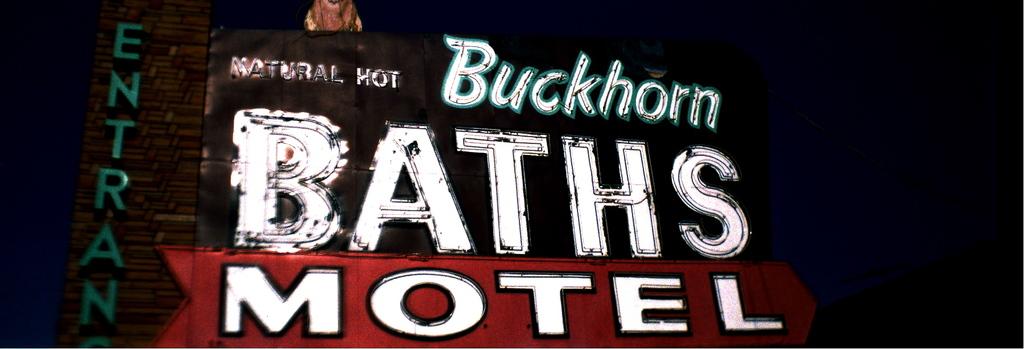What is the name of this motel?
Ensure brevity in your answer.  Buckhorn baths. What kind of baths does this imply that they have?
Provide a succinct answer. Buckhorn. 